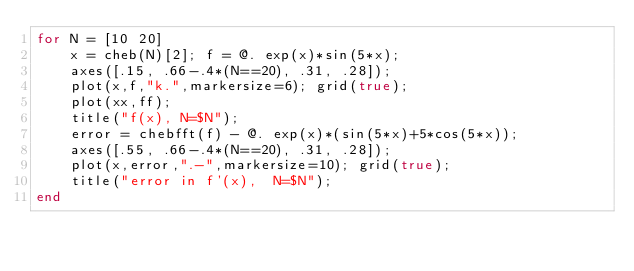Convert code to text. <code><loc_0><loc_0><loc_500><loc_500><_Julia_>for N = [10 20]
    x = cheb(N)[2]; f = @. exp(x)*sin(5*x);
    axes([.15, .66-.4*(N==20), .31, .28]);
    plot(x,f,"k.",markersize=6); grid(true);
    plot(xx,ff);
    title("f(x), N=$N");
    error = chebfft(f) - @. exp(x)*(sin(5*x)+5*cos(5*x));
    axes([.55, .66-.4*(N==20), .31, .28]);
    plot(x,error,".-",markersize=10); grid(true);
    title("error in f'(x),  N=$N");
end
</code> 